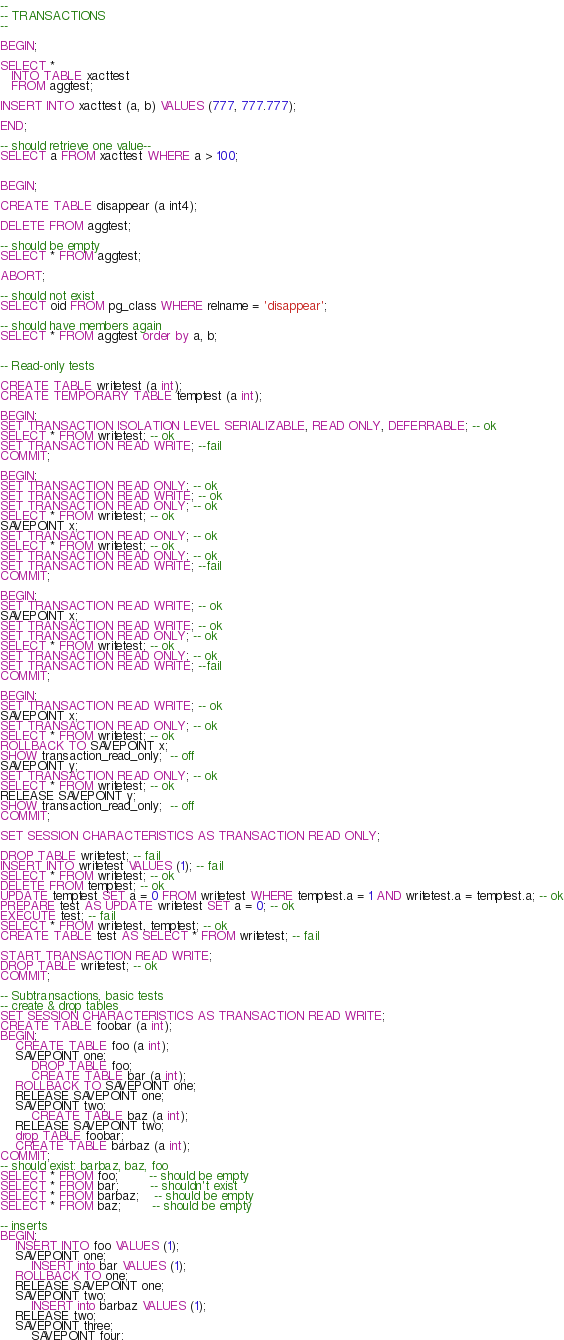<code> <loc_0><loc_0><loc_500><loc_500><_SQL_>--
-- TRANSACTIONS
--

BEGIN;

SELECT *
   INTO TABLE xacttest
   FROM aggtest;

INSERT INTO xacttest (a, b) VALUES (777, 777.777);

END;

-- should retrieve one value--
SELECT a FROM xacttest WHERE a > 100;


BEGIN;

CREATE TABLE disappear (a int4);

DELETE FROM aggtest;

-- should be empty
SELECT * FROM aggtest;

ABORT;

-- should not exist
SELECT oid FROM pg_class WHERE relname = 'disappear';

-- should have members again 
SELECT * FROM aggtest order by a, b;


-- Read-only tests

CREATE TABLE writetest (a int);
CREATE TEMPORARY TABLE temptest (a int);

BEGIN;
SET TRANSACTION ISOLATION LEVEL SERIALIZABLE, READ ONLY, DEFERRABLE; -- ok
SELECT * FROM writetest; -- ok
SET TRANSACTION READ WRITE; --fail
COMMIT;

BEGIN;
SET TRANSACTION READ ONLY; -- ok
SET TRANSACTION READ WRITE; -- ok
SET TRANSACTION READ ONLY; -- ok
SELECT * FROM writetest; -- ok
SAVEPOINT x;
SET TRANSACTION READ ONLY; -- ok
SELECT * FROM writetest; -- ok
SET TRANSACTION READ ONLY; -- ok
SET TRANSACTION READ WRITE; --fail
COMMIT;

BEGIN;
SET TRANSACTION READ WRITE; -- ok
SAVEPOINT x;
SET TRANSACTION READ WRITE; -- ok
SET TRANSACTION READ ONLY; -- ok
SELECT * FROM writetest; -- ok
SET TRANSACTION READ ONLY; -- ok
SET TRANSACTION READ WRITE; --fail
COMMIT;

BEGIN;
SET TRANSACTION READ WRITE; -- ok
SAVEPOINT x;
SET TRANSACTION READ ONLY; -- ok
SELECT * FROM writetest; -- ok
ROLLBACK TO SAVEPOINT x;
SHOW transaction_read_only;  -- off
SAVEPOINT y;
SET TRANSACTION READ ONLY; -- ok
SELECT * FROM writetest; -- ok
RELEASE SAVEPOINT y;
SHOW transaction_read_only;  -- off
COMMIT;

SET SESSION CHARACTERISTICS AS TRANSACTION READ ONLY;

DROP TABLE writetest; -- fail
INSERT INTO writetest VALUES (1); -- fail
SELECT * FROM writetest; -- ok
DELETE FROM temptest; -- ok
UPDATE temptest SET a = 0 FROM writetest WHERE temptest.a = 1 AND writetest.a = temptest.a; -- ok
PREPARE test AS UPDATE writetest SET a = 0; -- ok
EXECUTE test; -- fail
SELECT * FROM writetest, temptest; -- ok
CREATE TABLE test AS SELECT * FROM writetest; -- fail

START TRANSACTION READ WRITE;
DROP TABLE writetest; -- ok
COMMIT;

-- Subtransactions, basic tests
-- create & drop tables
SET SESSION CHARACTERISTICS AS TRANSACTION READ WRITE;
CREATE TABLE foobar (a int);
BEGIN;
	CREATE TABLE foo (a int);
	SAVEPOINT one;
		DROP TABLE foo;
		CREATE TABLE bar (a int);
	ROLLBACK TO SAVEPOINT one;
	RELEASE SAVEPOINT one;
	SAVEPOINT two;
		CREATE TABLE baz (a int);
	RELEASE SAVEPOINT two;
	drop TABLE foobar;
	CREATE TABLE barbaz (a int);
COMMIT;
-- should exist: barbaz, baz, foo
SELECT * FROM foo;		-- should be empty
SELECT * FROM bar;		-- shouldn't exist
SELECT * FROM barbaz;	-- should be empty
SELECT * FROM baz;		-- should be empty

-- inserts
BEGIN;
	INSERT INTO foo VALUES (1);
	SAVEPOINT one;
		INSERT into bar VALUES (1);
	ROLLBACK TO one;
	RELEASE SAVEPOINT one;
	SAVEPOINT two;
		INSERT into barbaz VALUES (1);
	RELEASE two;
	SAVEPOINT three;
		SAVEPOINT four;</code> 